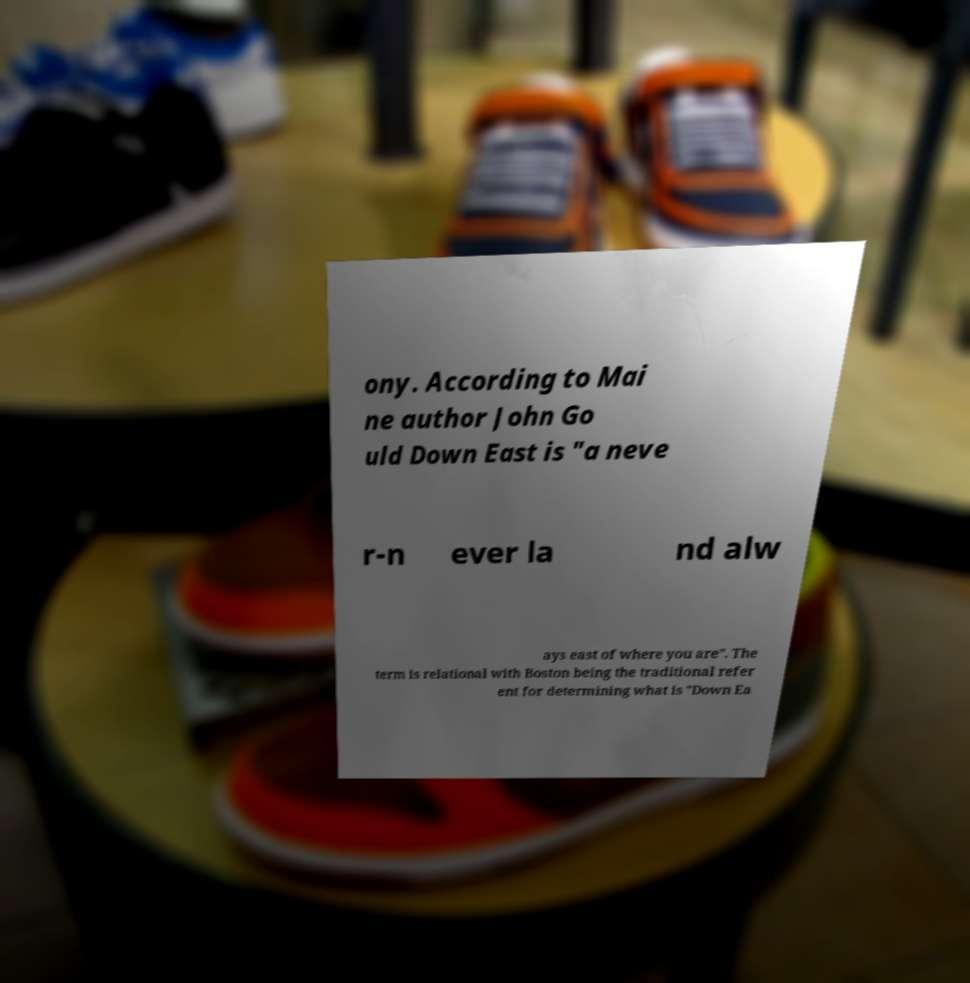Please read and relay the text visible in this image. What does it say? ony. According to Mai ne author John Go uld Down East is "a neve r-n ever la nd alw ays east of where you are". The term is relational with Boston being the traditional refer ent for determining what is "Down Ea 